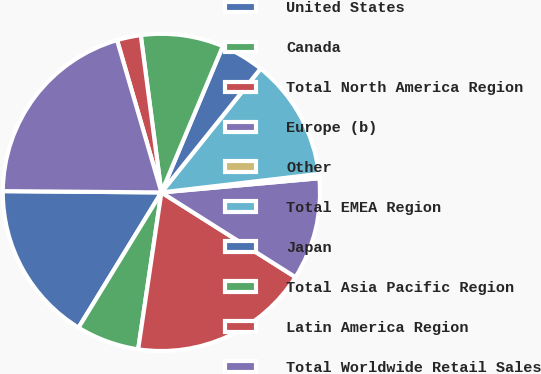Convert chart to OTSL. <chart><loc_0><loc_0><loc_500><loc_500><pie_chart><fcel>United States<fcel>Canada<fcel>Total North America Region<fcel>Europe (b)<fcel>Other<fcel>Total EMEA Region<fcel>Japan<fcel>Total Asia Pacific Region<fcel>Latin America Region<fcel>Total Worldwide Retail Sales<nl><fcel>16.38%<fcel>6.41%<fcel>18.37%<fcel>10.4%<fcel>0.43%<fcel>12.39%<fcel>4.42%<fcel>8.41%<fcel>2.43%<fcel>20.36%<nl></chart> 